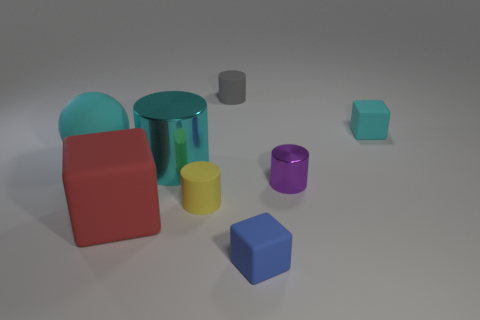Subtract 1 cylinders. How many cylinders are left? 3 Add 1 cyan rubber cylinders. How many objects exist? 9 Subtract all spheres. How many objects are left? 7 Subtract 0 red cylinders. How many objects are left? 8 Subtract all tiny yellow spheres. Subtract all small matte things. How many objects are left? 4 Add 5 purple shiny cylinders. How many purple shiny cylinders are left? 6 Add 4 matte spheres. How many matte spheres exist? 5 